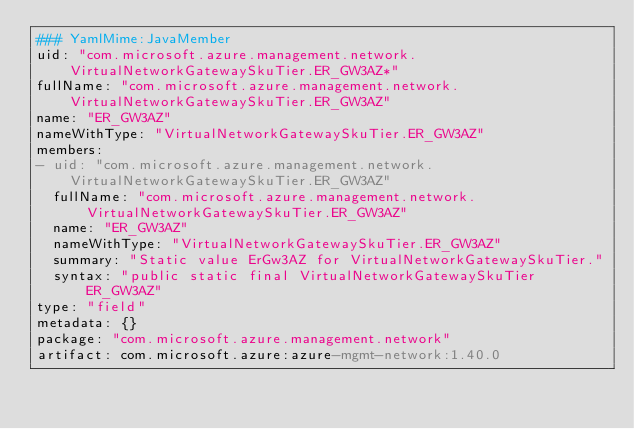<code> <loc_0><loc_0><loc_500><loc_500><_YAML_>### YamlMime:JavaMember
uid: "com.microsoft.azure.management.network.VirtualNetworkGatewaySkuTier.ER_GW3AZ*"
fullName: "com.microsoft.azure.management.network.VirtualNetworkGatewaySkuTier.ER_GW3AZ"
name: "ER_GW3AZ"
nameWithType: "VirtualNetworkGatewaySkuTier.ER_GW3AZ"
members:
- uid: "com.microsoft.azure.management.network.VirtualNetworkGatewaySkuTier.ER_GW3AZ"
  fullName: "com.microsoft.azure.management.network.VirtualNetworkGatewaySkuTier.ER_GW3AZ"
  name: "ER_GW3AZ"
  nameWithType: "VirtualNetworkGatewaySkuTier.ER_GW3AZ"
  summary: "Static value ErGw3AZ for VirtualNetworkGatewaySkuTier."
  syntax: "public static final VirtualNetworkGatewaySkuTier ER_GW3AZ"
type: "field"
metadata: {}
package: "com.microsoft.azure.management.network"
artifact: com.microsoft.azure:azure-mgmt-network:1.40.0
</code> 